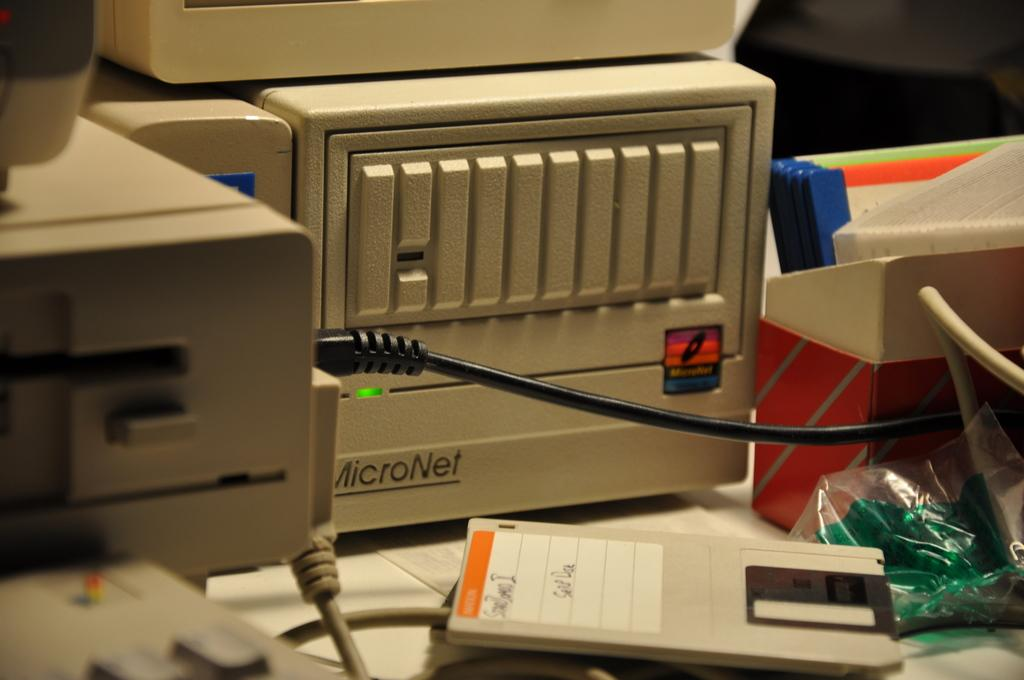<image>
Relay a brief, clear account of the picture shown. A Micronet Tower on a desk with a floppy disc in from to it. 